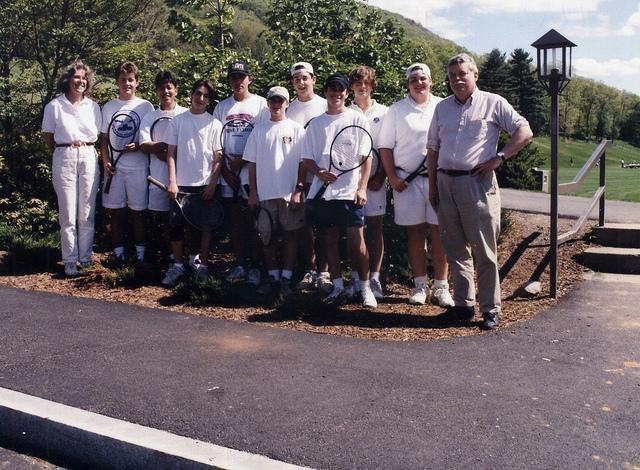How many people are in the photo?
Give a very brief answer. 11. 